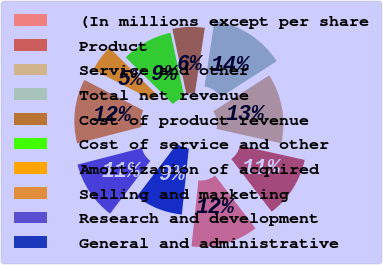Convert chart. <chart><loc_0><loc_0><loc_500><loc_500><pie_chart><fcel>(In millions except per share<fcel>Product<fcel>Service and other<fcel>Total net revenue<fcel>Cost of product revenue<fcel>Cost of service and other<fcel>Amortization of acquired<fcel>Selling and marketing<fcel>Research and development<fcel>General and administrative<nl><fcel>12.08%<fcel>11.11%<fcel>12.56%<fcel>13.53%<fcel>5.8%<fcel>9.18%<fcel>4.83%<fcel>11.59%<fcel>10.63%<fcel>8.7%<nl></chart> 